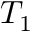<formula> <loc_0><loc_0><loc_500><loc_500>T _ { 1 }</formula> 